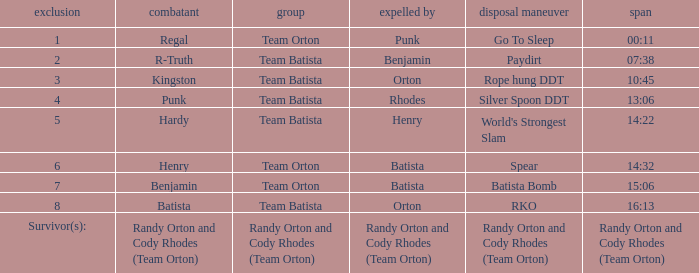Which Wrestler plays for Team Batista which was Elimated by Orton on Elimination 8? Batista. 